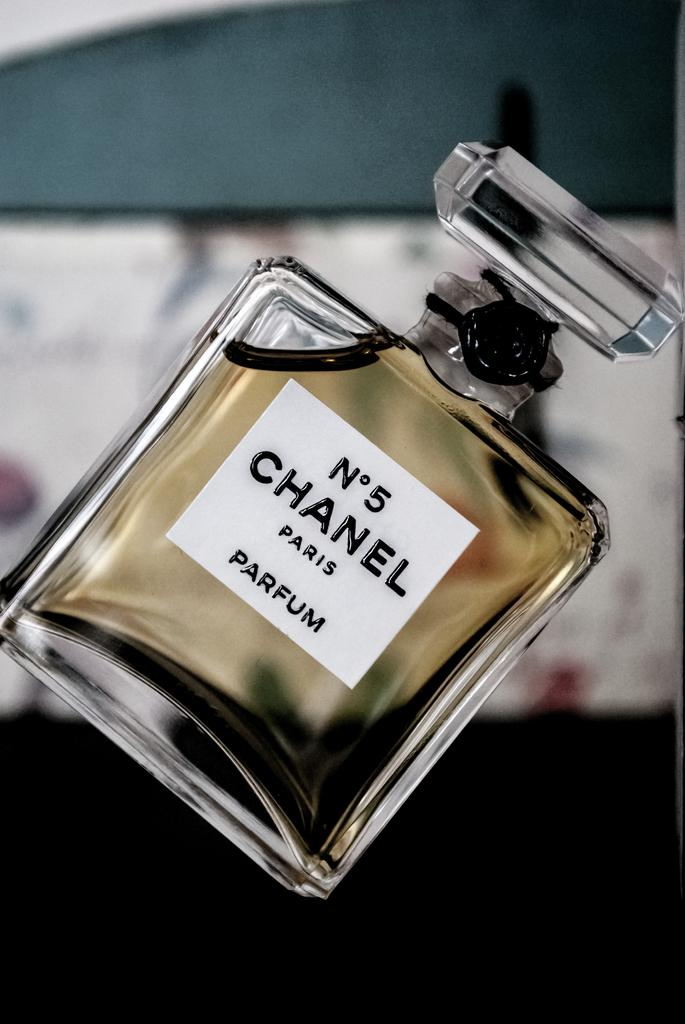<image>
Render a clear and concise summary of the photo. A bottle of perfume has a Chanel label on it. 